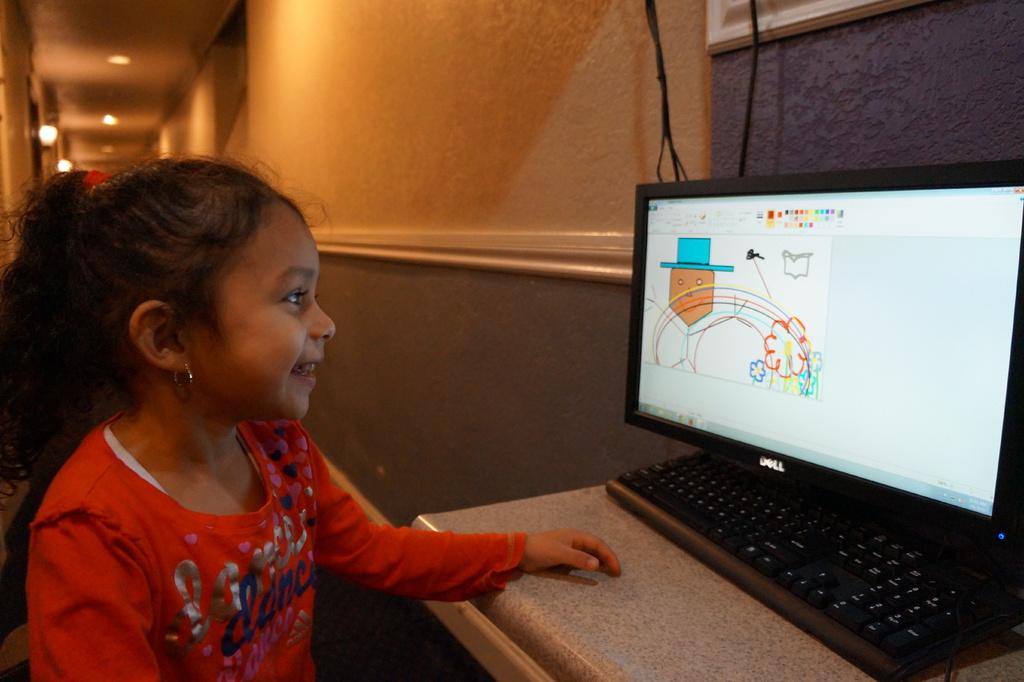What does her shirt say?
Make the answer very short. Dance. 